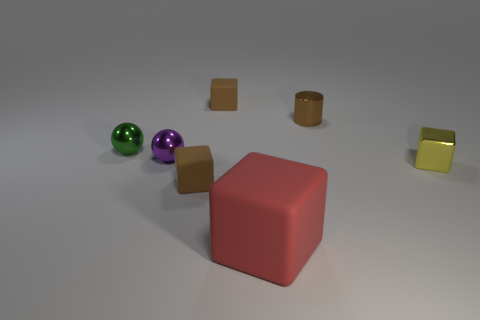There is a large red object that is the same shape as the yellow shiny object; what material is it?
Offer a very short reply. Rubber. Are there any small purple spheres?
Provide a succinct answer. Yes. There is a metallic thing that is to the right of the purple shiny sphere and in front of the small cylinder; what is its size?
Keep it short and to the point. Small. The yellow metal object has what shape?
Keep it short and to the point. Cube. Are there any small objects that are in front of the block to the right of the big rubber object?
Your answer should be very brief. Yes. Is there a brown metal cylinder of the same size as the green sphere?
Make the answer very short. Yes. What is the small brown thing that is in front of the cylinder made of?
Give a very brief answer. Rubber. Is the block that is behind the brown metallic cylinder made of the same material as the large red thing?
Provide a succinct answer. Yes. What is the shape of the purple metal object that is the same size as the green metallic thing?
Your response must be concise. Sphere. What number of objects have the same color as the big matte cube?
Your answer should be very brief. 0. 